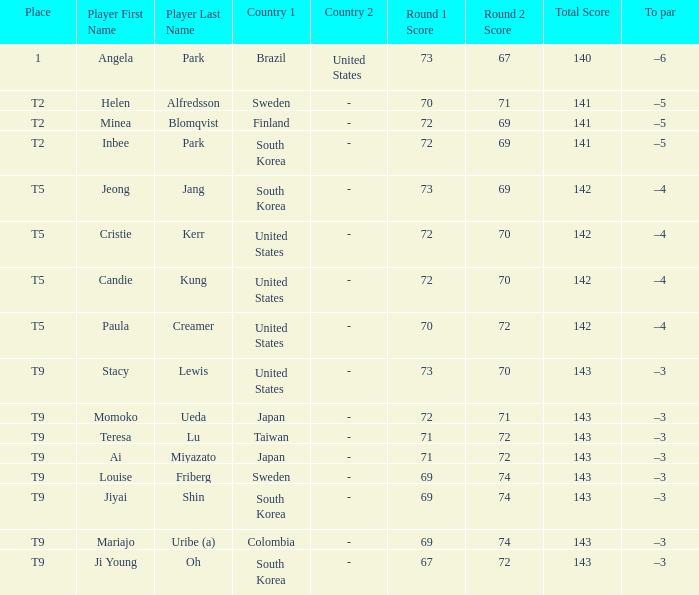What did Taiwan score? 71-72=143. 